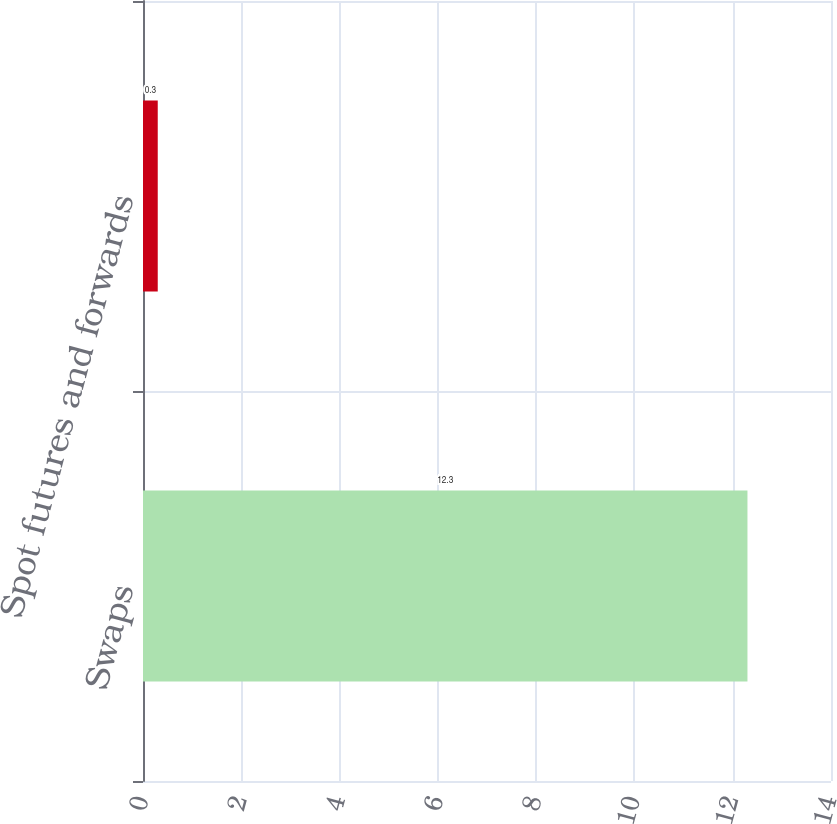Convert chart to OTSL. <chart><loc_0><loc_0><loc_500><loc_500><bar_chart><fcel>Swaps<fcel>Spot futures and forwards<nl><fcel>12.3<fcel>0.3<nl></chart> 